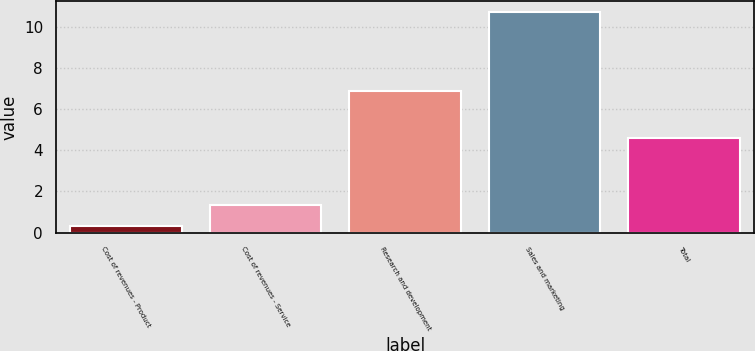<chart> <loc_0><loc_0><loc_500><loc_500><bar_chart><fcel>Cost of revenues - Product<fcel>Cost of revenues - Service<fcel>Research and development<fcel>Sales and marketing<fcel>Total<nl><fcel>0.3<fcel>1.34<fcel>6.9<fcel>10.7<fcel>4.6<nl></chart> 